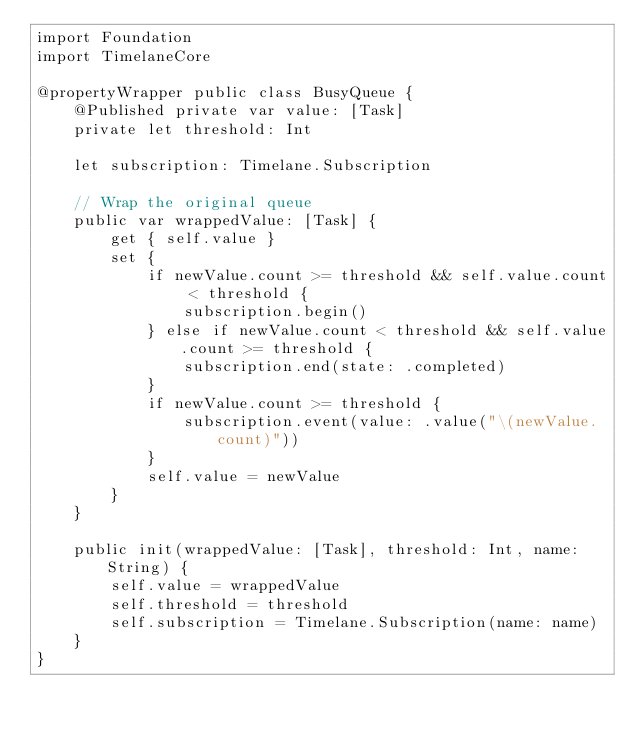Convert code to text. <code><loc_0><loc_0><loc_500><loc_500><_Swift_>import Foundation
import TimelaneCore

@propertyWrapper public class BusyQueue {
    @Published private var value: [Task]
    private let threshold: Int
    
    let subscription: Timelane.Subscription
    
    // Wrap the original queue
    public var wrappedValue: [Task] {
        get { self.value }
        set {
            if newValue.count >= threshold && self.value.count < threshold {
                subscription.begin()
            } else if newValue.count < threshold && self.value.count >= threshold {
                subscription.end(state: .completed)
            }
            if newValue.count >= threshold {
                subscription.event(value: .value("\(newValue.count)"))
            }
            self.value = newValue
        }
    }
    
    public init(wrappedValue: [Task], threshold: Int, name: String) {
        self.value = wrappedValue
        self.threshold = threshold
        self.subscription = Timelane.Subscription(name: name)
    }
}
</code> 